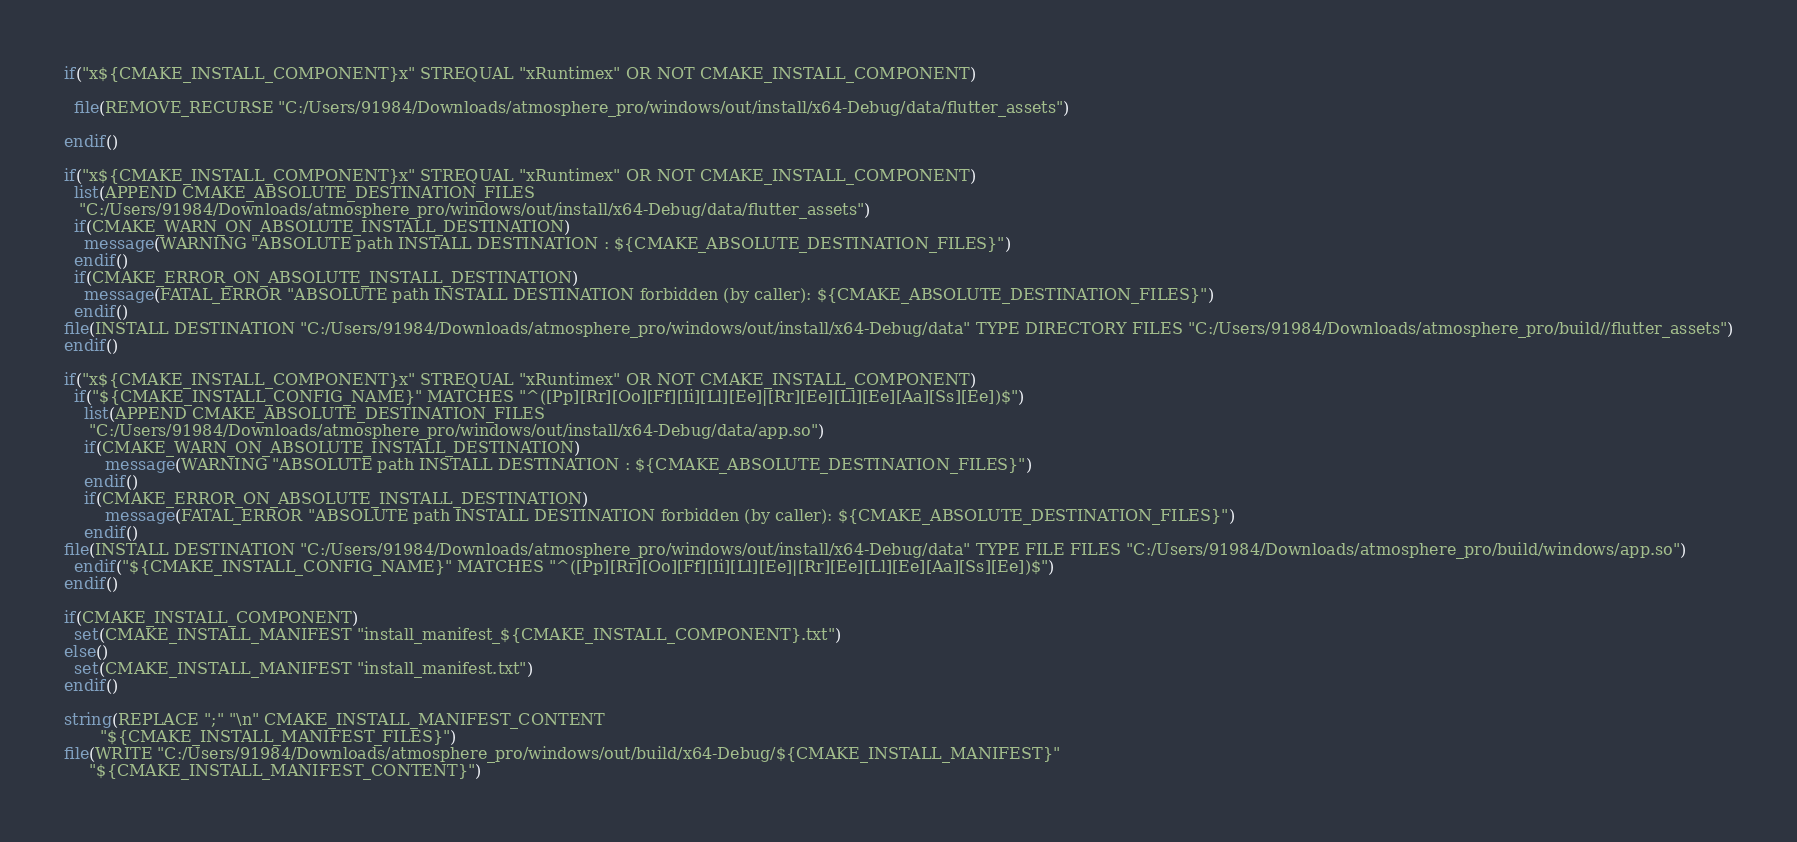<code> <loc_0><loc_0><loc_500><loc_500><_CMake_>if("x${CMAKE_INSTALL_COMPONENT}x" STREQUAL "xRuntimex" OR NOT CMAKE_INSTALL_COMPONENT)
  
  file(REMOVE_RECURSE "C:/Users/91984/Downloads/atmosphere_pro/windows/out/install/x64-Debug/data/flutter_assets")
  
endif()

if("x${CMAKE_INSTALL_COMPONENT}x" STREQUAL "xRuntimex" OR NOT CMAKE_INSTALL_COMPONENT)
  list(APPEND CMAKE_ABSOLUTE_DESTINATION_FILES
   "C:/Users/91984/Downloads/atmosphere_pro/windows/out/install/x64-Debug/data/flutter_assets")
  if(CMAKE_WARN_ON_ABSOLUTE_INSTALL_DESTINATION)
    message(WARNING "ABSOLUTE path INSTALL DESTINATION : ${CMAKE_ABSOLUTE_DESTINATION_FILES}")
  endif()
  if(CMAKE_ERROR_ON_ABSOLUTE_INSTALL_DESTINATION)
    message(FATAL_ERROR "ABSOLUTE path INSTALL DESTINATION forbidden (by caller): ${CMAKE_ABSOLUTE_DESTINATION_FILES}")
  endif()
file(INSTALL DESTINATION "C:/Users/91984/Downloads/atmosphere_pro/windows/out/install/x64-Debug/data" TYPE DIRECTORY FILES "C:/Users/91984/Downloads/atmosphere_pro/build//flutter_assets")
endif()

if("x${CMAKE_INSTALL_COMPONENT}x" STREQUAL "xRuntimex" OR NOT CMAKE_INSTALL_COMPONENT)
  if("${CMAKE_INSTALL_CONFIG_NAME}" MATCHES "^([Pp][Rr][Oo][Ff][Ii][Ll][Ee]|[Rr][Ee][Ll][Ee][Aa][Ss][Ee])$")
    list(APPEND CMAKE_ABSOLUTE_DESTINATION_FILES
     "C:/Users/91984/Downloads/atmosphere_pro/windows/out/install/x64-Debug/data/app.so")
    if(CMAKE_WARN_ON_ABSOLUTE_INSTALL_DESTINATION)
        message(WARNING "ABSOLUTE path INSTALL DESTINATION : ${CMAKE_ABSOLUTE_DESTINATION_FILES}")
    endif()
    if(CMAKE_ERROR_ON_ABSOLUTE_INSTALL_DESTINATION)
        message(FATAL_ERROR "ABSOLUTE path INSTALL DESTINATION forbidden (by caller): ${CMAKE_ABSOLUTE_DESTINATION_FILES}")
    endif()
file(INSTALL DESTINATION "C:/Users/91984/Downloads/atmosphere_pro/windows/out/install/x64-Debug/data" TYPE FILE FILES "C:/Users/91984/Downloads/atmosphere_pro/build/windows/app.so")
  endif("${CMAKE_INSTALL_CONFIG_NAME}" MATCHES "^([Pp][Rr][Oo][Ff][Ii][Ll][Ee]|[Rr][Ee][Ll][Ee][Aa][Ss][Ee])$")
endif()

if(CMAKE_INSTALL_COMPONENT)
  set(CMAKE_INSTALL_MANIFEST "install_manifest_${CMAKE_INSTALL_COMPONENT}.txt")
else()
  set(CMAKE_INSTALL_MANIFEST "install_manifest.txt")
endif()

string(REPLACE ";" "\n" CMAKE_INSTALL_MANIFEST_CONTENT
       "${CMAKE_INSTALL_MANIFEST_FILES}")
file(WRITE "C:/Users/91984/Downloads/atmosphere_pro/windows/out/build/x64-Debug/${CMAKE_INSTALL_MANIFEST}"
     "${CMAKE_INSTALL_MANIFEST_CONTENT}")
</code> 